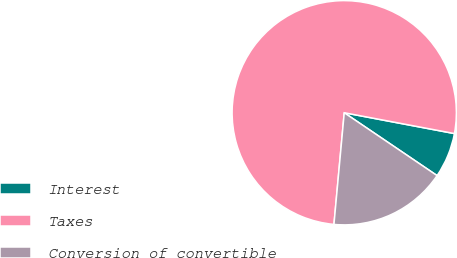Convert chart to OTSL. <chart><loc_0><loc_0><loc_500><loc_500><pie_chart><fcel>Interest<fcel>Taxes<fcel>Conversion of convertible<nl><fcel>6.5%<fcel>76.51%<fcel>16.99%<nl></chart> 